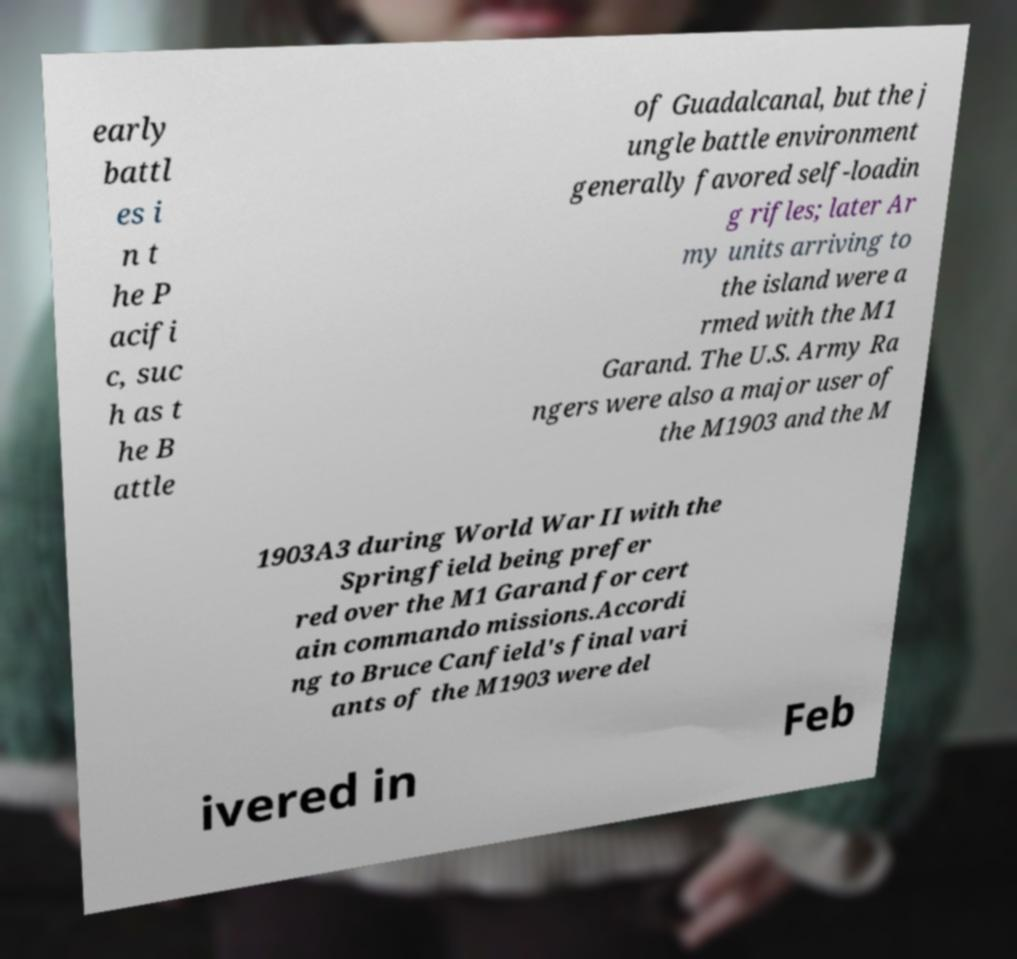Could you extract and type out the text from this image? early battl es i n t he P acifi c, suc h as t he B attle of Guadalcanal, but the j ungle battle environment generally favored self-loadin g rifles; later Ar my units arriving to the island were a rmed with the M1 Garand. The U.S. Army Ra ngers were also a major user of the M1903 and the M 1903A3 during World War II with the Springfield being prefer red over the M1 Garand for cert ain commando missions.Accordi ng to Bruce Canfield's final vari ants of the M1903 were del ivered in Feb 